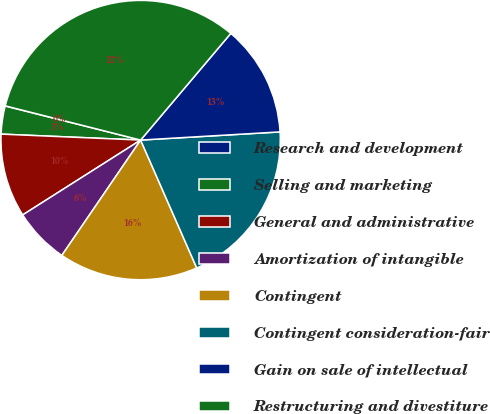<chart> <loc_0><loc_0><loc_500><loc_500><pie_chart><fcel>Research and development<fcel>Selling and marketing<fcel>General and administrative<fcel>Amortization of intangible<fcel>Contingent<fcel>Contingent consideration-fair<fcel>Gain on sale of intellectual<fcel>Restructuring and divestiture<nl><fcel>0.02%<fcel>3.24%<fcel>9.68%<fcel>6.46%<fcel>16.12%<fcel>19.35%<fcel>12.9%<fcel>32.23%<nl></chart> 